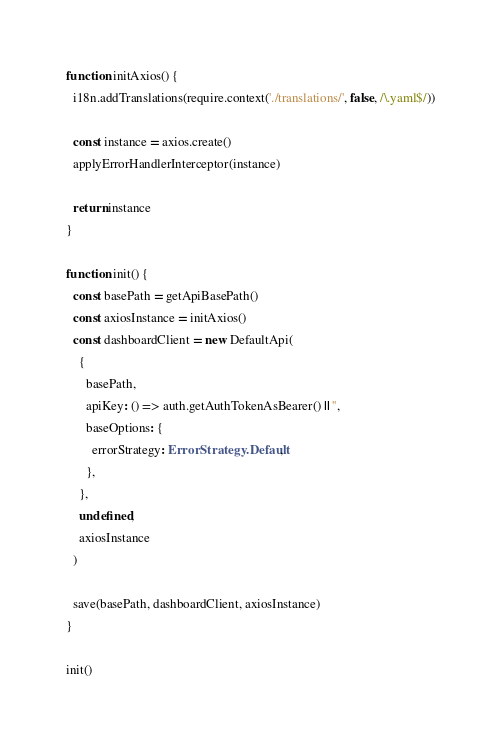Convert code to text. <code><loc_0><loc_0><loc_500><loc_500><_TypeScript_>
function initAxios() {
  i18n.addTranslations(require.context('./translations/', false, /\.yaml$/))

  const instance = axios.create()
  applyErrorHandlerInterceptor(instance)

  return instance
}

function init() {
  const basePath = getApiBasePath()
  const axiosInstance = initAxios()
  const dashboardClient = new DefaultApi(
    {
      basePath,
      apiKey: () => auth.getAuthTokenAsBearer() || '',
      baseOptions: {
        errorStrategy: ErrorStrategy.Default,
      },
    },
    undefined,
    axiosInstance
  )

  save(basePath, dashboardClient, axiosInstance)
}

init()
</code> 